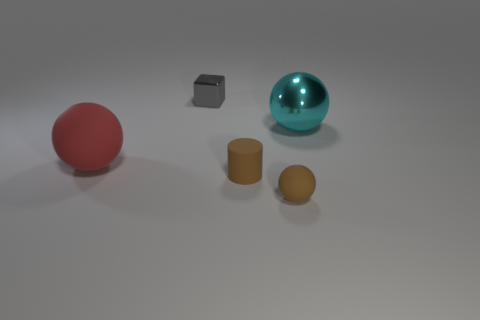How many objects are objects that are on the left side of the matte cylinder or tiny blue cylinders?
Offer a terse response. 2. Is the number of small rubber spheres behind the red sphere the same as the number of big spheres in front of the large cyan metallic ball?
Ensure brevity in your answer.  No. How many other objects are the same shape as the cyan metal thing?
Your answer should be compact. 2. Is the size of the matte thing left of the gray metallic cube the same as the cyan shiny thing that is to the right of the gray cube?
Make the answer very short. Yes. How many blocks are big matte objects or tiny things?
Ensure brevity in your answer.  1. How many rubber things are cylinders or small things?
Offer a terse response. 2. There is a brown matte thing that is the same shape as the cyan metallic object; what size is it?
Your response must be concise. Small. Is there any other thing that is the same size as the brown rubber sphere?
Make the answer very short. Yes. Is the size of the brown sphere the same as the gray object that is to the right of the red sphere?
Offer a very short reply. Yes. The tiny object behind the cyan metallic ball has what shape?
Provide a succinct answer. Cube. 